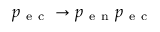Convert formula to latex. <formula><loc_0><loc_0><loc_500><loc_500>p _ { e c } \rightarrow p _ { e n } p _ { e c }</formula> 